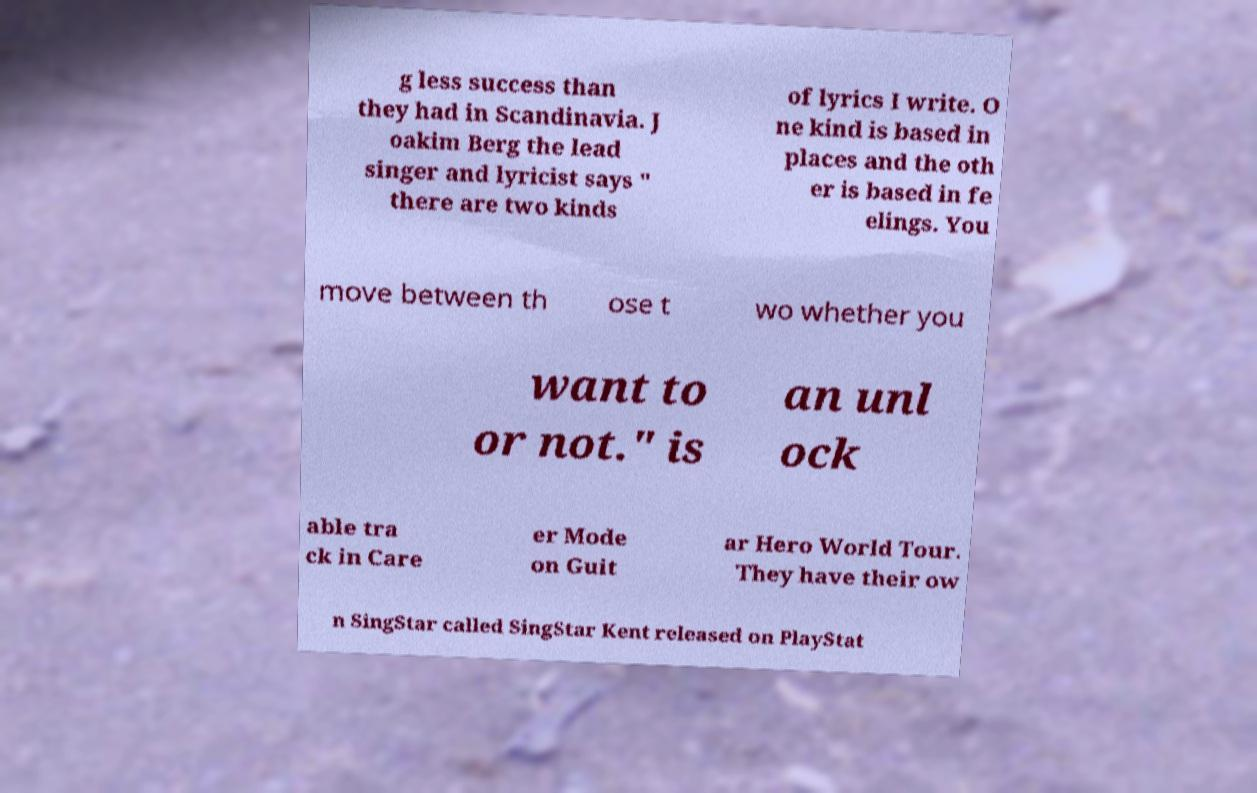For documentation purposes, I need the text within this image transcribed. Could you provide that? g less success than they had in Scandinavia. J oakim Berg the lead singer and lyricist says " there are two kinds of lyrics I write. O ne kind is based in places and the oth er is based in fe elings. You move between th ose t wo whether you want to or not." is an unl ock able tra ck in Care er Mode on Guit ar Hero World Tour. They have their ow n SingStar called SingStar Kent released on PlayStat 